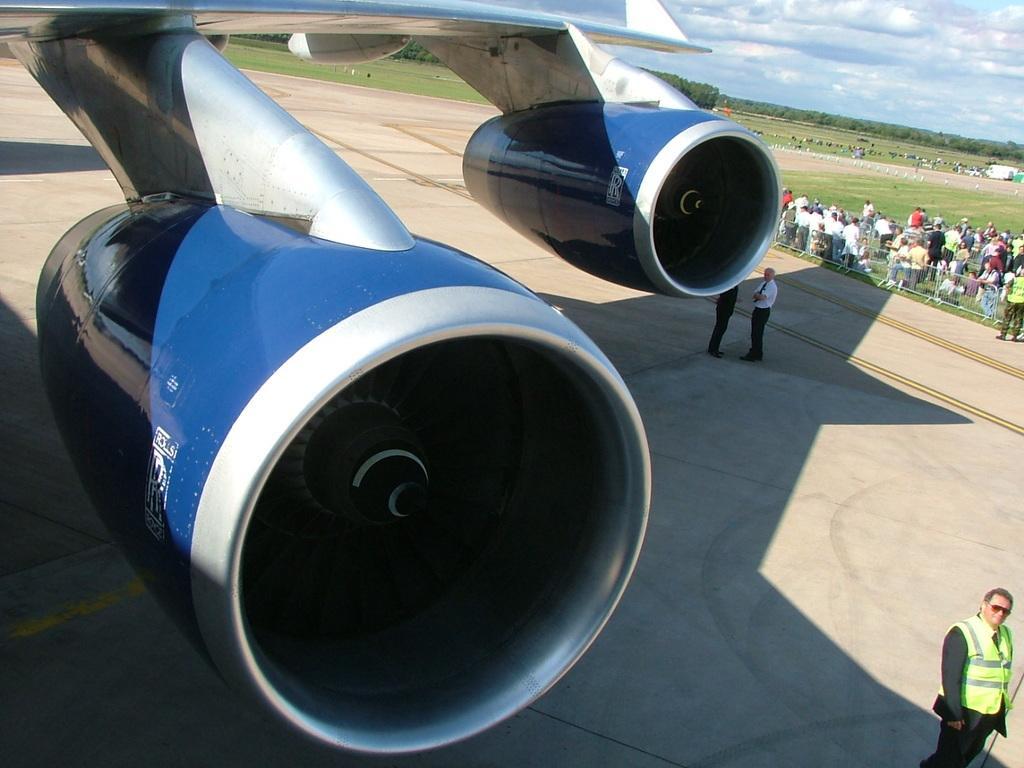Describe this image in one or two sentences. In this image I see an aeroplane and I see the path and I see number of people. In the background I see the green grass and I see number of trees and I see the sky. 